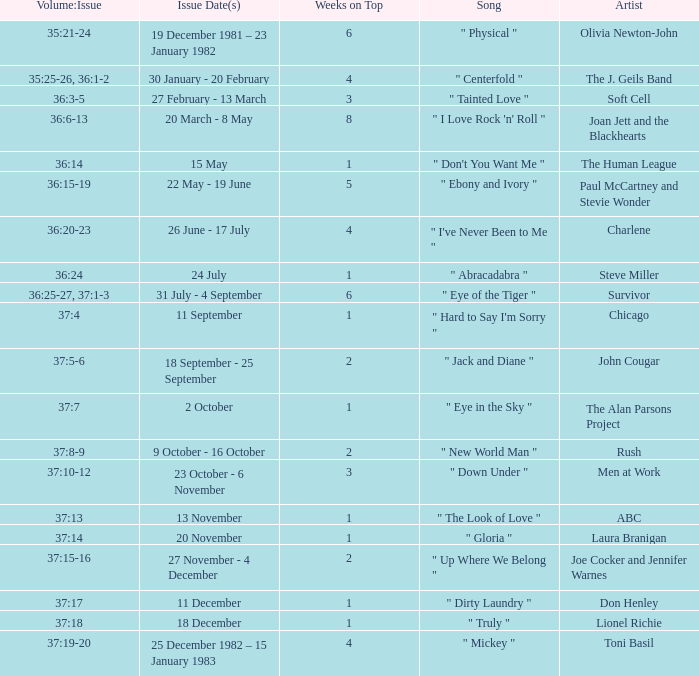On what issue date(s) can an artist be found portraying men at work? 23 October - 6 November. Parse the table in full. {'header': ['Volume:Issue', 'Issue Date(s)', 'Weeks on Top', 'Song', 'Artist'], 'rows': [['35:21-24', '19 December 1981 – 23 January 1982', '6', '" Physical "', 'Olivia Newton-John'], ['35:25-26, 36:1-2', '30 January - 20 February', '4', '" Centerfold "', 'The J. Geils Band'], ['36:3-5', '27 February - 13 March', '3', '" Tainted Love "', 'Soft Cell'], ['36:6-13', '20 March - 8 May', '8', '" I Love Rock \'n\' Roll "', 'Joan Jett and the Blackhearts'], ['36:14', '15 May', '1', '" Don\'t You Want Me "', 'The Human League'], ['36:15-19', '22 May - 19 June', '5', '" Ebony and Ivory "', 'Paul McCartney and Stevie Wonder'], ['36:20-23', '26 June - 17 July', '4', '" I\'ve Never Been to Me "', 'Charlene'], ['36:24', '24 July', '1', '" Abracadabra "', 'Steve Miller'], ['36:25-27, 37:1-3', '31 July - 4 September', '6', '" Eye of the Tiger "', 'Survivor'], ['37:4', '11 September', '1', '" Hard to Say I\'m Sorry "', 'Chicago'], ['37:5-6', '18 September - 25 September', '2', '" Jack and Diane "', 'John Cougar'], ['37:7', '2 October', '1', '" Eye in the Sky "', 'The Alan Parsons Project'], ['37:8-9', '9 October - 16 October', '2', '" New World Man "', 'Rush'], ['37:10-12', '23 October - 6 November', '3', '" Down Under "', 'Men at Work'], ['37:13', '13 November', '1', '" The Look of Love "', 'ABC'], ['37:14', '20 November', '1', '" Gloria "', 'Laura Branigan'], ['37:15-16', '27 November - 4 December', '2', '" Up Where We Belong "', 'Joe Cocker and Jennifer Warnes'], ['37:17', '11 December', '1', '" Dirty Laundry "', 'Don Henley'], ['37:18', '18 December', '1', '" Truly "', 'Lionel Richie'], ['37:19-20', '25 December 1982 – 15 January 1983', '4', '" Mickey "', 'Toni Basil']]} 